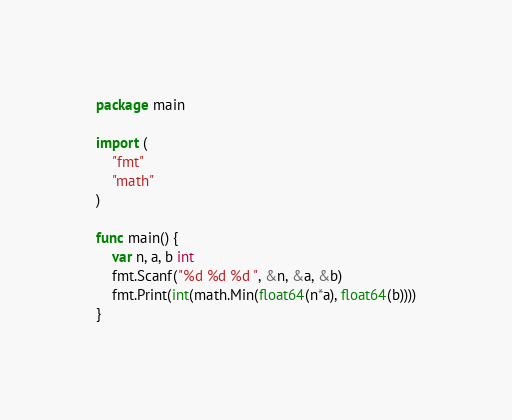Convert code to text. <code><loc_0><loc_0><loc_500><loc_500><_Go_>package main

import (
	"fmt"
	"math"
)

func main() {
	var n, a, b int
	fmt.Scanf("%d %d %d ", &n, &a, &b)
	fmt.Print(int(math.Min(float64(n*a), float64(b))))
}</code> 